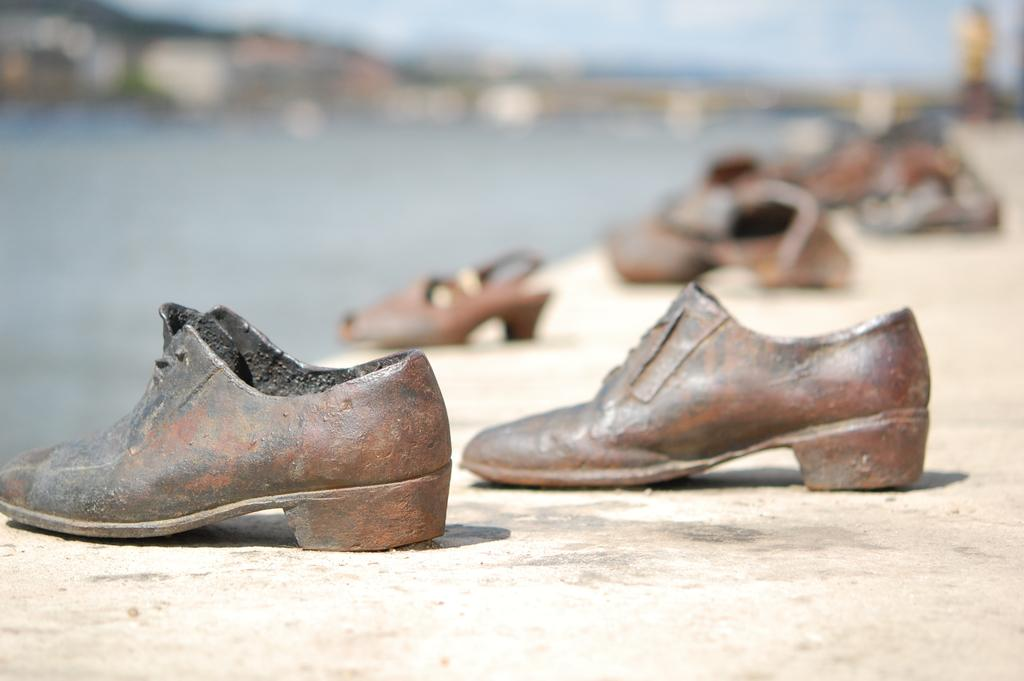What objects are on the ground in the image? There are shoes on the ground in the image. Can you describe the background of the image? The background of the image is blurred. What type of goat can be seen in the image? There is no goat present in the image; it only features shoes on the ground and a blurred background. 